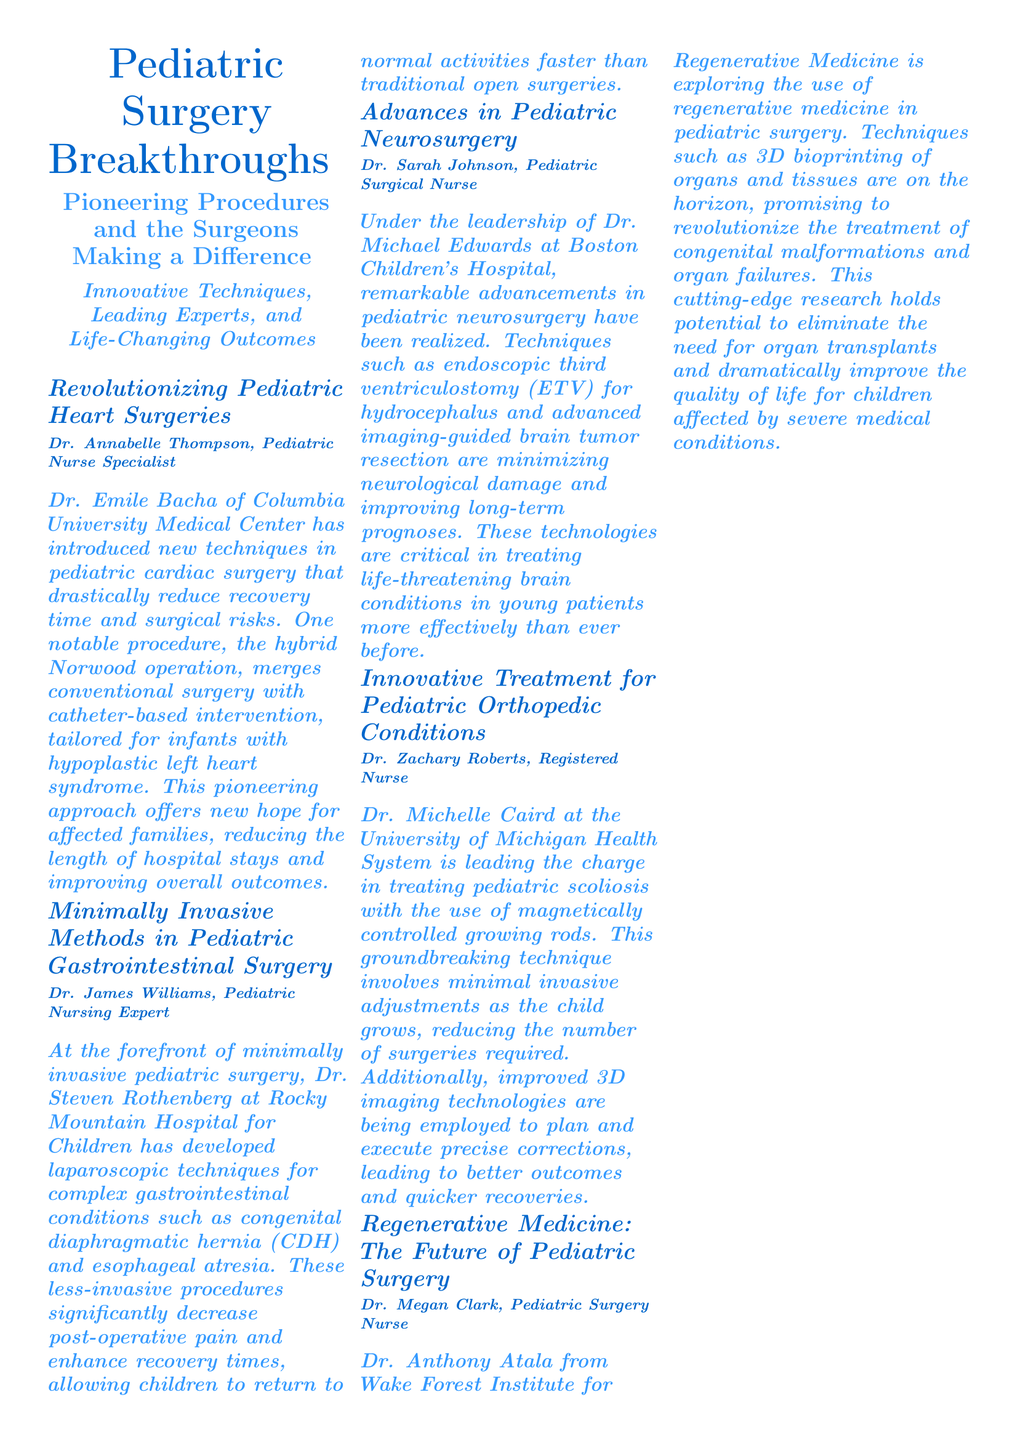What is the name of the surgeon associated with pediatric heart surgeries? Dr. Emile Bacha is mentioned in the document as the surgeon associated with pediatric heart surgeries.
Answer: Dr. Emile Bacha What innovative procedure has Dr. Emile Bacha introduced? The document states that Dr. Emile Bacha introduced the hybrid Norwood operation.
Answer: hybrid Norwood operation Which hospital is Dr. Steven Rothenberg affiliated with? The document mentions that Dr. Steven Rothenberg is affiliated with Rocky Mountain Hospital for Children.
Answer: Rocky Mountain Hospital for Children What is the success rate for pediatric surgery mentioned in the document? The success rate listed in the document is 97%.
Answer: 97% Who is the featured surgeon in the document? The document provides the name of the featured surgeon as Dr. Carla Perez.
Answer: Dr. Carla Perez What type of conditions is Dr. Michelle Caird treating? The document states that Dr. Michelle Caird is treating pediatric scoliosis.
Answer: pediatric scoliosis What innovative technology is Dr. Anthony Atala exploring? The document describes Dr. Anthony Atala as exploring regenerative medicine, particularly 3D bioprinting.
Answer: regenerative medicine, 3D bioprinting When is the Global Pediatric Surgery Summit 2023 scheduled? The document indicates that the Global Pediatric Surgery Summit 2023 is scheduled for November.
Answer: November What is the average recovery time stated in the document? The average recovery time mentioned in the document is 2 weeks.
Answer: 2 weeks 